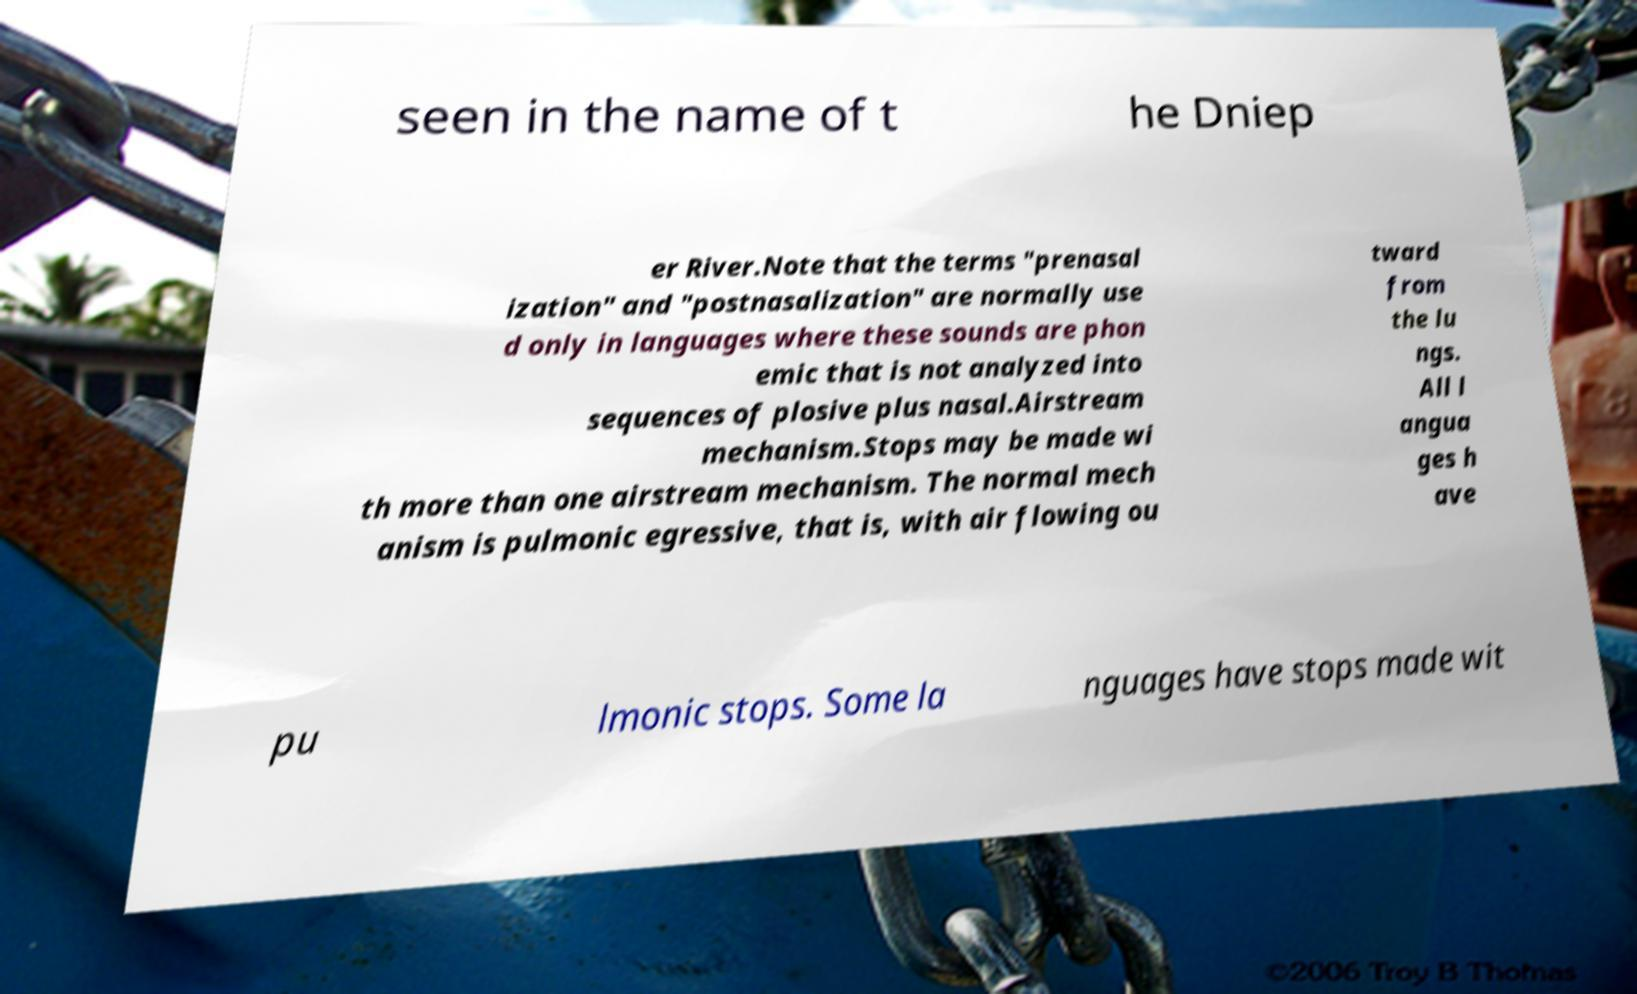Please read and relay the text visible in this image. What does it say? seen in the name of t he Dniep er River.Note that the terms "prenasal ization" and "postnasalization" are normally use d only in languages where these sounds are phon emic that is not analyzed into sequences of plosive plus nasal.Airstream mechanism.Stops may be made wi th more than one airstream mechanism. The normal mech anism is pulmonic egressive, that is, with air flowing ou tward from the lu ngs. All l angua ges h ave pu lmonic stops. Some la nguages have stops made wit 